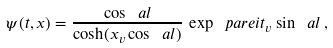<formula> <loc_0><loc_0><loc_500><loc_500>\psi ( t , x ) = \frac { \cos \ a l } { \cosh ( x _ { v } \cos \ a l ) } \, \exp \ p a r e { i t _ { v } \sin \ a l } \, ,</formula> 